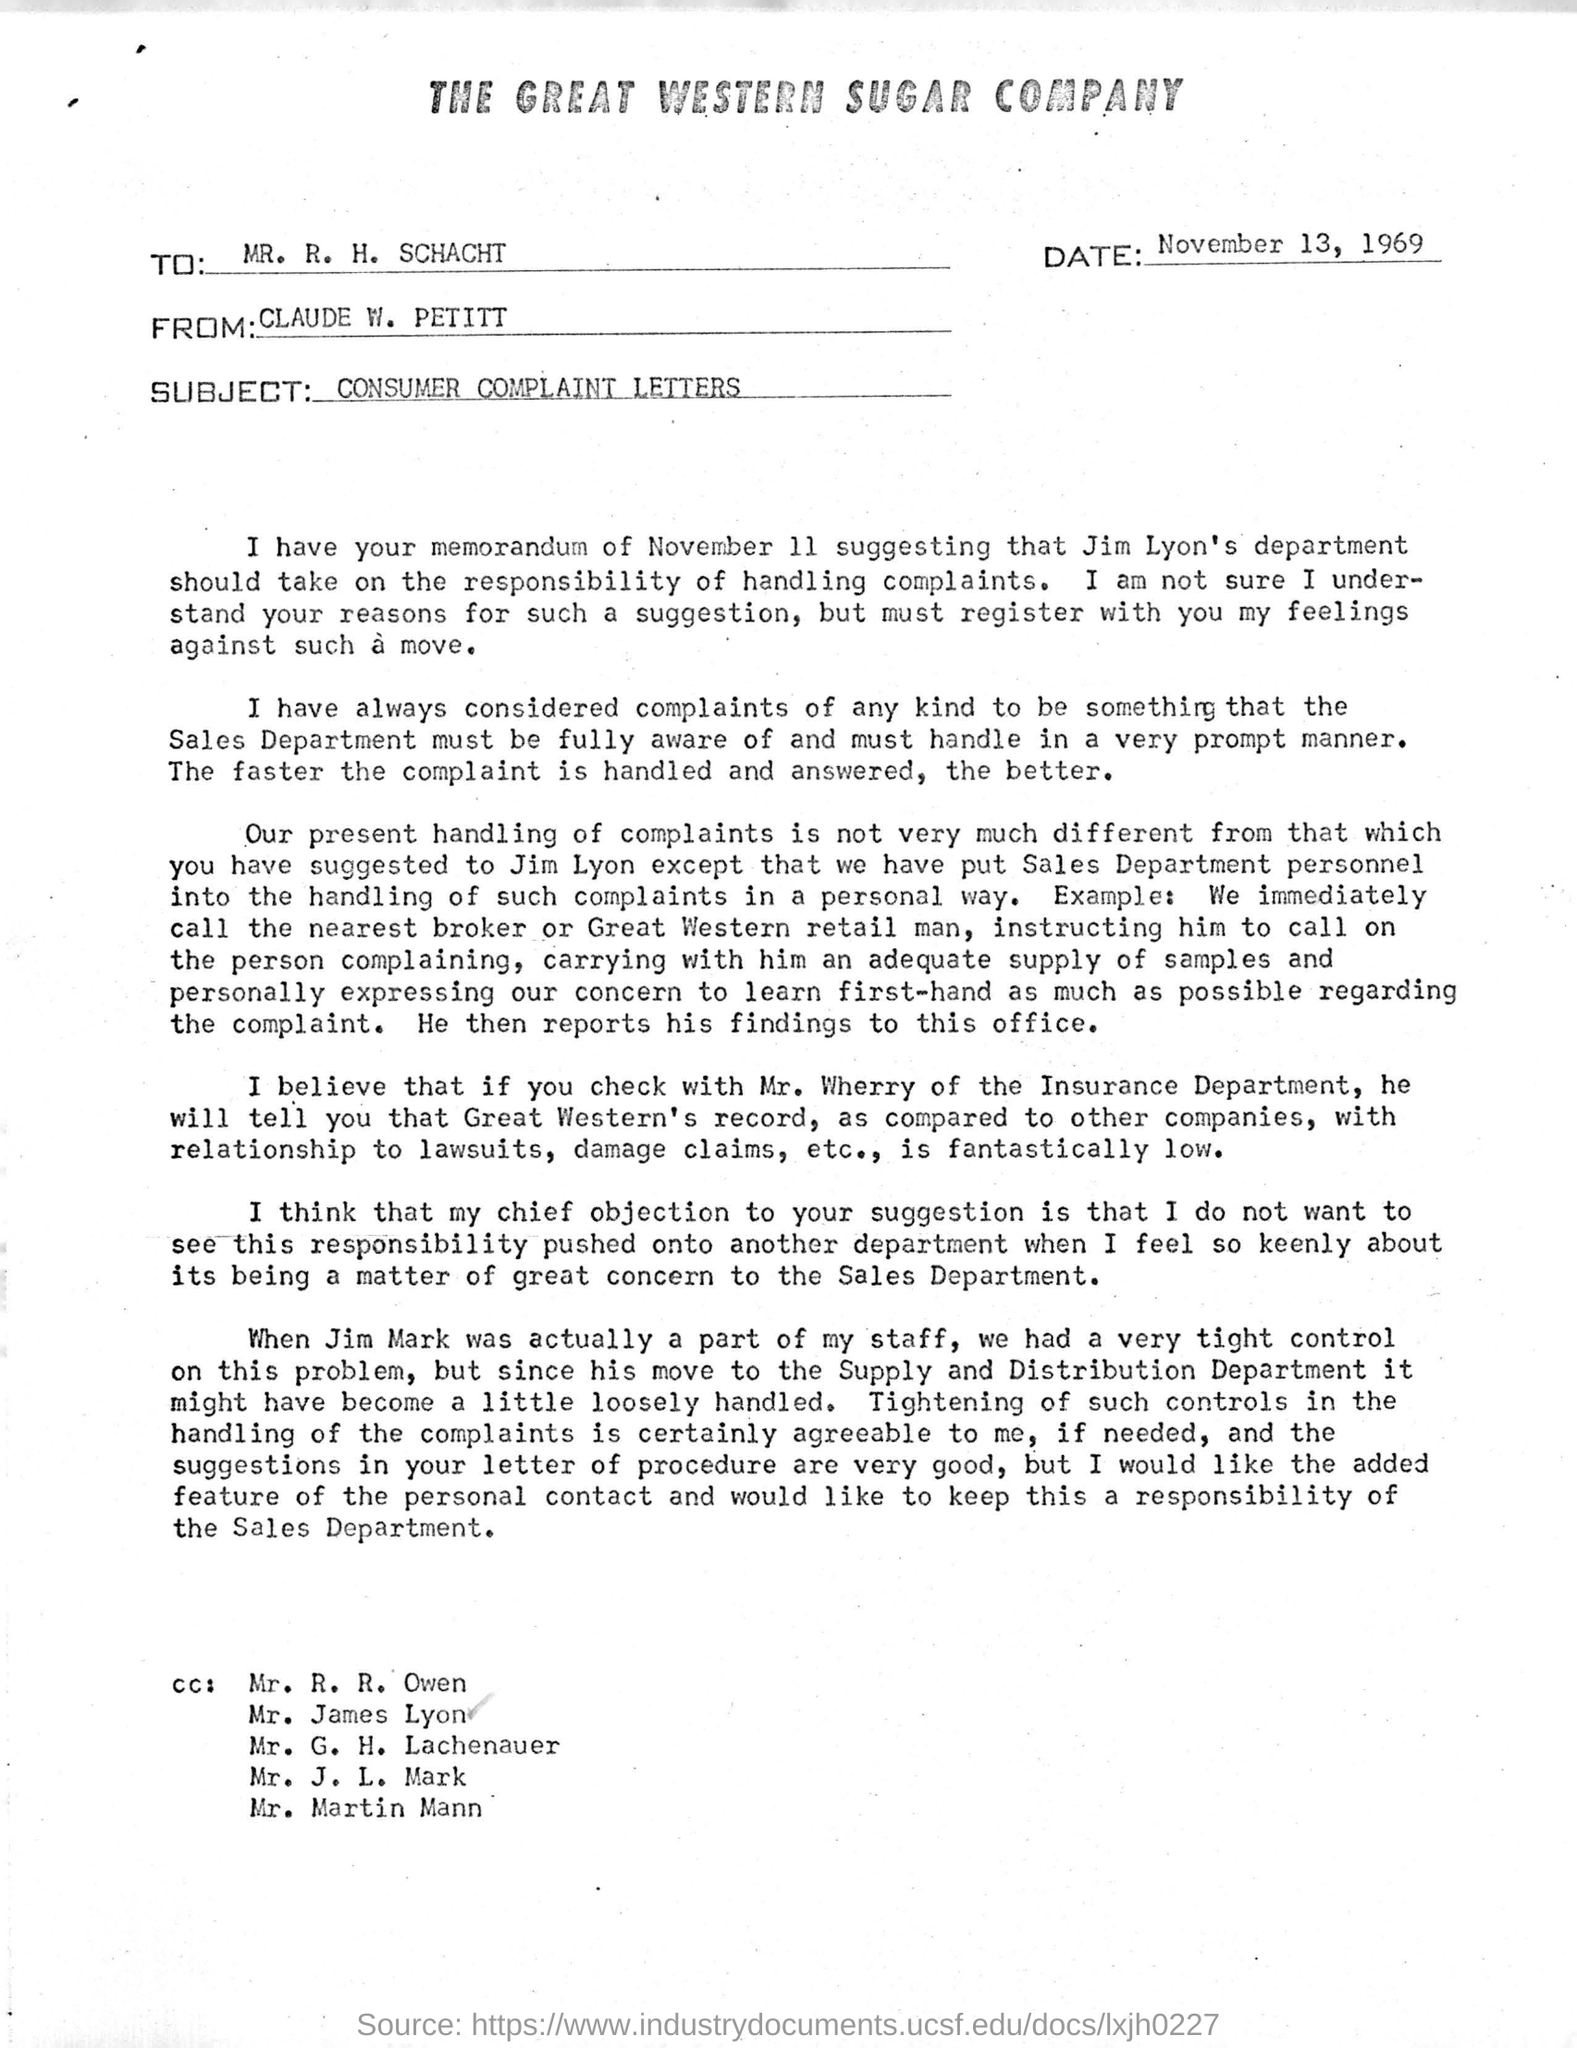Highlight a few significant elements in this photo. The date mentioned is November 13, 1969. The heading of the document is "The Great Western Sugar Company. The subject of this email is "CONSUMER COMPLAINT LETTERS. 